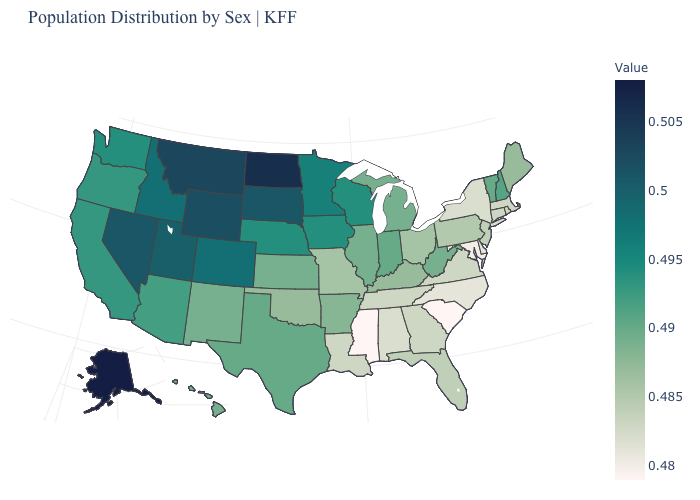Does Mississippi have the lowest value in the USA?
Keep it brief. Yes. Is the legend a continuous bar?
Write a very short answer. Yes. Among the states that border New Hampshire , which have the lowest value?
Short answer required. Massachusetts. Which states have the lowest value in the USA?
Keep it brief. Mississippi, South Carolina. Is the legend a continuous bar?
Give a very brief answer. Yes. Among the states that border Pennsylvania , does Maryland have the lowest value?
Concise answer only. Yes. Does Missouri have the highest value in the MidWest?
Quick response, please. No. 